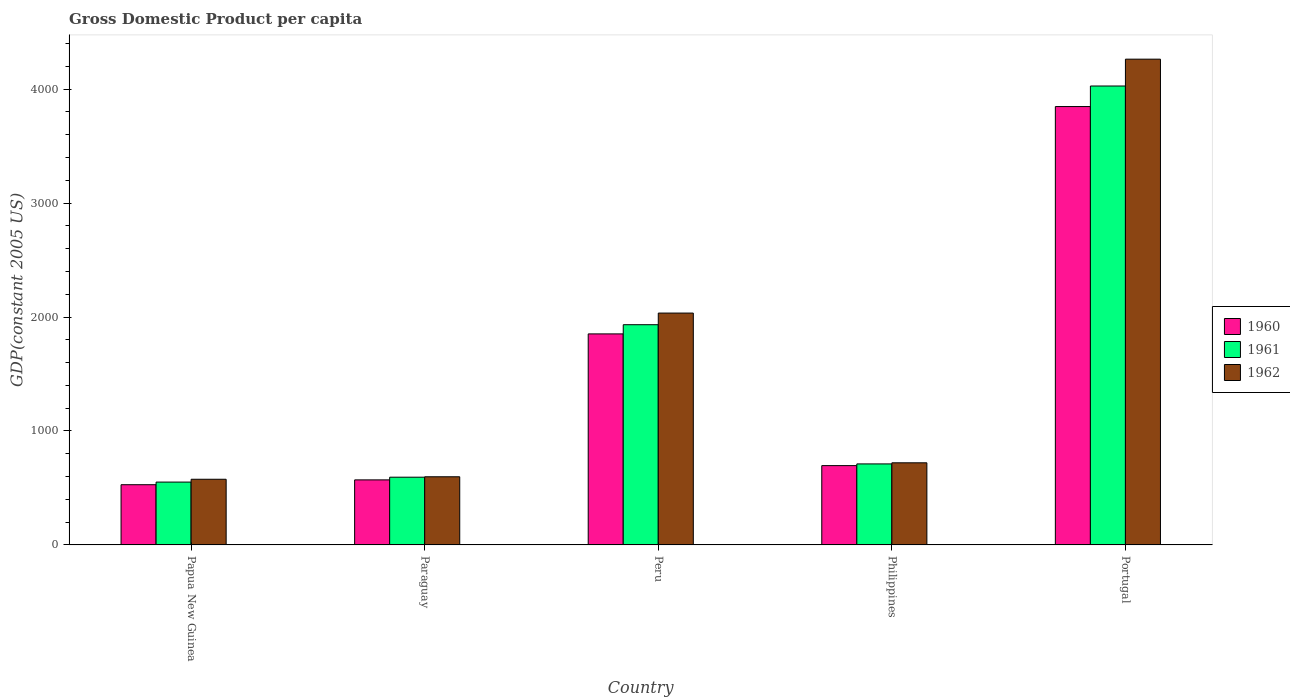How many groups of bars are there?
Provide a succinct answer. 5. Are the number of bars per tick equal to the number of legend labels?
Your answer should be very brief. Yes. Are the number of bars on each tick of the X-axis equal?
Make the answer very short. Yes. How many bars are there on the 5th tick from the right?
Your response must be concise. 3. What is the label of the 4th group of bars from the left?
Your response must be concise. Philippines. What is the GDP per capita in 1962 in Paraguay?
Make the answer very short. 598.08. Across all countries, what is the maximum GDP per capita in 1962?
Make the answer very short. 4262.56. Across all countries, what is the minimum GDP per capita in 1962?
Your answer should be compact. 576.26. In which country was the GDP per capita in 1961 maximum?
Your response must be concise. Portugal. In which country was the GDP per capita in 1962 minimum?
Ensure brevity in your answer.  Papua New Guinea. What is the total GDP per capita in 1960 in the graph?
Give a very brief answer. 7493.66. What is the difference between the GDP per capita in 1962 in Papua New Guinea and that in Peru?
Your answer should be very brief. -1458.28. What is the difference between the GDP per capita in 1961 in Paraguay and the GDP per capita in 1962 in Portugal?
Give a very brief answer. -3668.18. What is the average GDP per capita in 1960 per country?
Ensure brevity in your answer.  1498.73. What is the difference between the GDP per capita of/in 1961 and GDP per capita of/in 1962 in Peru?
Offer a very short reply. -102.11. What is the ratio of the GDP per capita in 1961 in Peru to that in Portugal?
Keep it short and to the point. 0.48. Is the GDP per capita in 1962 in Paraguay less than that in Portugal?
Your answer should be compact. Yes. What is the difference between the highest and the second highest GDP per capita in 1961?
Keep it short and to the point. 2094.64. What is the difference between the highest and the lowest GDP per capita in 1962?
Make the answer very short. 3686.3. In how many countries, is the GDP per capita in 1960 greater than the average GDP per capita in 1960 taken over all countries?
Offer a very short reply. 2. Is the sum of the GDP per capita in 1962 in Paraguay and Peru greater than the maximum GDP per capita in 1961 across all countries?
Your answer should be very brief. No. Does the graph contain any zero values?
Your answer should be very brief. No. Does the graph contain grids?
Keep it short and to the point. No. Where does the legend appear in the graph?
Offer a terse response. Center right. How many legend labels are there?
Provide a short and direct response. 3. How are the legend labels stacked?
Keep it short and to the point. Vertical. What is the title of the graph?
Your response must be concise. Gross Domestic Product per capita. Does "1963" appear as one of the legend labels in the graph?
Your answer should be very brief. No. What is the label or title of the Y-axis?
Offer a very short reply. GDP(constant 2005 US). What is the GDP(constant 2005 US) of 1960 in Papua New Guinea?
Offer a very short reply. 528.4. What is the GDP(constant 2005 US) of 1961 in Papua New Guinea?
Your answer should be very brief. 551.5. What is the GDP(constant 2005 US) in 1962 in Papua New Guinea?
Your response must be concise. 576.26. What is the GDP(constant 2005 US) of 1960 in Paraguay?
Provide a succinct answer. 570.76. What is the GDP(constant 2005 US) in 1961 in Paraguay?
Offer a terse response. 594.38. What is the GDP(constant 2005 US) in 1962 in Paraguay?
Keep it short and to the point. 598.08. What is the GDP(constant 2005 US) in 1960 in Peru?
Give a very brief answer. 1851.77. What is the GDP(constant 2005 US) in 1961 in Peru?
Provide a succinct answer. 1932.43. What is the GDP(constant 2005 US) of 1962 in Peru?
Offer a very short reply. 2034.54. What is the GDP(constant 2005 US) of 1960 in Philippines?
Provide a succinct answer. 696.02. What is the GDP(constant 2005 US) of 1961 in Philippines?
Your response must be concise. 710.98. What is the GDP(constant 2005 US) of 1962 in Philippines?
Your answer should be compact. 720.61. What is the GDP(constant 2005 US) of 1960 in Portugal?
Offer a terse response. 3846.7. What is the GDP(constant 2005 US) in 1961 in Portugal?
Your response must be concise. 4027.06. What is the GDP(constant 2005 US) of 1962 in Portugal?
Provide a short and direct response. 4262.56. Across all countries, what is the maximum GDP(constant 2005 US) in 1960?
Offer a very short reply. 3846.7. Across all countries, what is the maximum GDP(constant 2005 US) in 1961?
Ensure brevity in your answer.  4027.06. Across all countries, what is the maximum GDP(constant 2005 US) in 1962?
Offer a very short reply. 4262.56. Across all countries, what is the minimum GDP(constant 2005 US) in 1960?
Offer a very short reply. 528.4. Across all countries, what is the minimum GDP(constant 2005 US) in 1961?
Keep it short and to the point. 551.5. Across all countries, what is the minimum GDP(constant 2005 US) of 1962?
Ensure brevity in your answer.  576.26. What is the total GDP(constant 2005 US) of 1960 in the graph?
Your answer should be very brief. 7493.66. What is the total GDP(constant 2005 US) of 1961 in the graph?
Make the answer very short. 7816.36. What is the total GDP(constant 2005 US) in 1962 in the graph?
Make the answer very short. 8192.03. What is the difference between the GDP(constant 2005 US) in 1960 in Papua New Guinea and that in Paraguay?
Your answer should be very brief. -42.36. What is the difference between the GDP(constant 2005 US) in 1961 in Papua New Guinea and that in Paraguay?
Keep it short and to the point. -42.88. What is the difference between the GDP(constant 2005 US) of 1962 in Papua New Guinea and that in Paraguay?
Offer a very short reply. -21.82. What is the difference between the GDP(constant 2005 US) of 1960 in Papua New Guinea and that in Peru?
Offer a very short reply. -1323.37. What is the difference between the GDP(constant 2005 US) of 1961 in Papua New Guinea and that in Peru?
Provide a short and direct response. -1380.92. What is the difference between the GDP(constant 2005 US) of 1962 in Papua New Guinea and that in Peru?
Offer a terse response. -1458.28. What is the difference between the GDP(constant 2005 US) in 1960 in Papua New Guinea and that in Philippines?
Offer a very short reply. -167.62. What is the difference between the GDP(constant 2005 US) in 1961 in Papua New Guinea and that in Philippines?
Your answer should be very brief. -159.48. What is the difference between the GDP(constant 2005 US) in 1962 in Papua New Guinea and that in Philippines?
Give a very brief answer. -144.35. What is the difference between the GDP(constant 2005 US) of 1960 in Papua New Guinea and that in Portugal?
Give a very brief answer. -3318.3. What is the difference between the GDP(constant 2005 US) of 1961 in Papua New Guinea and that in Portugal?
Your response must be concise. -3475.56. What is the difference between the GDP(constant 2005 US) of 1962 in Papua New Guinea and that in Portugal?
Your answer should be compact. -3686.3. What is the difference between the GDP(constant 2005 US) of 1960 in Paraguay and that in Peru?
Ensure brevity in your answer.  -1281.01. What is the difference between the GDP(constant 2005 US) in 1961 in Paraguay and that in Peru?
Ensure brevity in your answer.  -1338.04. What is the difference between the GDP(constant 2005 US) of 1962 in Paraguay and that in Peru?
Provide a short and direct response. -1436.46. What is the difference between the GDP(constant 2005 US) in 1960 in Paraguay and that in Philippines?
Provide a short and direct response. -125.26. What is the difference between the GDP(constant 2005 US) of 1961 in Paraguay and that in Philippines?
Your response must be concise. -116.6. What is the difference between the GDP(constant 2005 US) of 1962 in Paraguay and that in Philippines?
Provide a succinct answer. -122.53. What is the difference between the GDP(constant 2005 US) in 1960 in Paraguay and that in Portugal?
Offer a very short reply. -3275.94. What is the difference between the GDP(constant 2005 US) in 1961 in Paraguay and that in Portugal?
Your answer should be very brief. -3432.68. What is the difference between the GDP(constant 2005 US) of 1962 in Paraguay and that in Portugal?
Make the answer very short. -3664.48. What is the difference between the GDP(constant 2005 US) in 1960 in Peru and that in Philippines?
Ensure brevity in your answer.  1155.75. What is the difference between the GDP(constant 2005 US) in 1961 in Peru and that in Philippines?
Offer a very short reply. 1221.44. What is the difference between the GDP(constant 2005 US) in 1962 in Peru and that in Philippines?
Offer a terse response. 1313.93. What is the difference between the GDP(constant 2005 US) of 1960 in Peru and that in Portugal?
Make the answer very short. -1994.93. What is the difference between the GDP(constant 2005 US) of 1961 in Peru and that in Portugal?
Your response must be concise. -2094.64. What is the difference between the GDP(constant 2005 US) in 1962 in Peru and that in Portugal?
Keep it short and to the point. -2228.02. What is the difference between the GDP(constant 2005 US) in 1960 in Philippines and that in Portugal?
Offer a very short reply. -3150.68. What is the difference between the GDP(constant 2005 US) of 1961 in Philippines and that in Portugal?
Ensure brevity in your answer.  -3316.08. What is the difference between the GDP(constant 2005 US) in 1962 in Philippines and that in Portugal?
Your response must be concise. -3541.95. What is the difference between the GDP(constant 2005 US) in 1960 in Papua New Guinea and the GDP(constant 2005 US) in 1961 in Paraguay?
Offer a terse response. -65.98. What is the difference between the GDP(constant 2005 US) in 1960 in Papua New Guinea and the GDP(constant 2005 US) in 1962 in Paraguay?
Provide a short and direct response. -69.68. What is the difference between the GDP(constant 2005 US) in 1961 in Papua New Guinea and the GDP(constant 2005 US) in 1962 in Paraguay?
Offer a very short reply. -46.57. What is the difference between the GDP(constant 2005 US) of 1960 in Papua New Guinea and the GDP(constant 2005 US) of 1961 in Peru?
Offer a terse response. -1404.03. What is the difference between the GDP(constant 2005 US) in 1960 in Papua New Guinea and the GDP(constant 2005 US) in 1962 in Peru?
Provide a succinct answer. -1506.14. What is the difference between the GDP(constant 2005 US) of 1961 in Papua New Guinea and the GDP(constant 2005 US) of 1962 in Peru?
Provide a short and direct response. -1483.04. What is the difference between the GDP(constant 2005 US) of 1960 in Papua New Guinea and the GDP(constant 2005 US) of 1961 in Philippines?
Give a very brief answer. -182.58. What is the difference between the GDP(constant 2005 US) in 1960 in Papua New Guinea and the GDP(constant 2005 US) in 1962 in Philippines?
Make the answer very short. -192.21. What is the difference between the GDP(constant 2005 US) in 1961 in Papua New Guinea and the GDP(constant 2005 US) in 1962 in Philippines?
Provide a succinct answer. -169.1. What is the difference between the GDP(constant 2005 US) of 1960 in Papua New Guinea and the GDP(constant 2005 US) of 1961 in Portugal?
Make the answer very short. -3498.66. What is the difference between the GDP(constant 2005 US) in 1960 in Papua New Guinea and the GDP(constant 2005 US) in 1962 in Portugal?
Make the answer very short. -3734.16. What is the difference between the GDP(constant 2005 US) of 1961 in Papua New Guinea and the GDP(constant 2005 US) of 1962 in Portugal?
Give a very brief answer. -3711.06. What is the difference between the GDP(constant 2005 US) of 1960 in Paraguay and the GDP(constant 2005 US) of 1961 in Peru?
Ensure brevity in your answer.  -1361.67. What is the difference between the GDP(constant 2005 US) in 1960 in Paraguay and the GDP(constant 2005 US) in 1962 in Peru?
Your answer should be compact. -1463.78. What is the difference between the GDP(constant 2005 US) of 1961 in Paraguay and the GDP(constant 2005 US) of 1962 in Peru?
Your answer should be very brief. -1440.15. What is the difference between the GDP(constant 2005 US) in 1960 in Paraguay and the GDP(constant 2005 US) in 1961 in Philippines?
Keep it short and to the point. -140.22. What is the difference between the GDP(constant 2005 US) of 1960 in Paraguay and the GDP(constant 2005 US) of 1962 in Philippines?
Your answer should be compact. -149.84. What is the difference between the GDP(constant 2005 US) of 1961 in Paraguay and the GDP(constant 2005 US) of 1962 in Philippines?
Make the answer very short. -126.22. What is the difference between the GDP(constant 2005 US) of 1960 in Paraguay and the GDP(constant 2005 US) of 1961 in Portugal?
Offer a very short reply. -3456.3. What is the difference between the GDP(constant 2005 US) of 1960 in Paraguay and the GDP(constant 2005 US) of 1962 in Portugal?
Offer a terse response. -3691.8. What is the difference between the GDP(constant 2005 US) in 1961 in Paraguay and the GDP(constant 2005 US) in 1962 in Portugal?
Provide a short and direct response. -3668.18. What is the difference between the GDP(constant 2005 US) of 1960 in Peru and the GDP(constant 2005 US) of 1961 in Philippines?
Keep it short and to the point. 1140.79. What is the difference between the GDP(constant 2005 US) in 1960 in Peru and the GDP(constant 2005 US) in 1962 in Philippines?
Give a very brief answer. 1131.17. What is the difference between the GDP(constant 2005 US) in 1961 in Peru and the GDP(constant 2005 US) in 1962 in Philippines?
Provide a short and direct response. 1211.82. What is the difference between the GDP(constant 2005 US) in 1960 in Peru and the GDP(constant 2005 US) in 1961 in Portugal?
Your answer should be compact. -2175.29. What is the difference between the GDP(constant 2005 US) in 1960 in Peru and the GDP(constant 2005 US) in 1962 in Portugal?
Your response must be concise. -2410.79. What is the difference between the GDP(constant 2005 US) of 1961 in Peru and the GDP(constant 2005 US) of 1962 in Portugal?
Keep it short and to the point. -2330.13. What is the difference between the GDP(constant 2005 US) of 1960 in Philippines and the GDP(constant 2005 US) of 1961 in Portugal?
Provide a succinct answer. -3331.04. What is the difference between the GDP(constant 2005 US) in 1960 in Philippines and the GDP(constant 2005 US) in 1962 in Portugal?
Offer a terse response. -3566.54. What is the difference between the GDP(constant 2005 US) in 1961 in Philippines and the GDP(constant 2005 US) in 1962 in Portugal?
Offer a very short reply. -3551.57. What is the average GDP(constant 2005 US) of 1960 per country?
Offer a terse response. 1498.73. What is the average GDP(constant 2005 US) in 1961 per country?
Your answer should be compact. 1563.27. What is the average GDP(constant 2005 US) of 1962 per country?
Keep it short and to the point. 1638.41. What is the difference between the GDP(constant 2005 US) of 1960 and GDP(constant 2005 US) of 1961 in Papua New Guinea?
Offer a terse response. -23.1. What is the difference between the GDP(constant 2005 US) in 1960 and GDP(constant 2005 US) in 1962 in Papua New Guinea?
Offer a very short reply. -47.85. What is the difference between the GDP(constant 2005 US) of 1961 and GDP(constant 2005 US) of 1962 in Papua New Guinea?
Offer a terse response. -24.75. What is the difference between the GDP(constant 2005 US) in 1960 and GDP(constant 2005 US) in 1961 in Paraguay?
Ensure brevity in your answer.  -23.62. What is the difference between the GDP(constant 2005 US) of 1960 and GDP(constant 2005 US) of 1962 in Paraguay?
Provide a short and direct response. -27.32. What is the difference between the GDP(constant 2005 US) of 1961 and GDP(constant 2005 US) of 1962 in Paraguay?
Ensure brevity in your answer.  -3.69. What is the difference between the GDP(constant 2005 US) in 1960 and GDP(constant 2005 US) in 1961 in Peru?
Your answer should be compact. -80.65. What is the difference between the GDP(constant 2005 US) in 1960 and GDP(constant 2005 US) in 1962 in Peru?
Ensure brevity in your answer.  -182.77. What is the difference between the GDP(constant 2005 US) in 1961 and GDP(constant 2005 US) in 1962 in Peru?
Your response must be concise. -102.11. What is the difference between the GDP(constant 2005 US) of 1960 and GDP(constant 2005 US) of 1961 in Philippines?
Provide a short and direct response. -14.96. What is the difference between the GDP(constant 2005 US) of 1960 and GDP(constant 2005 US) of 1962 in Philippines?
Offer a terse response. -24.59. What is the difference between the GDP(constant 2005 US) in 1961 and GDP(constant 2005 US) in 1962 in Philippines?
Provide a short and direct response. -9.62. What is the difference between the GDP(constant 2005 US) of 1960 and GDP(constant 2005 US) of 1961 in Portugal?
Offer a terse response. -180.36. What is the difference between the GDP(constant 2005 US) of 1960 and GDP(constant 2005 US) of 1962 in Portugal?
Provide a succinct answer. -415.86. What is the difference between the GDP(constant 2005 US) in 1961 and GDP(constant 2005 US) in 1962 in Portugal?
Provide a succinct answer. -235.5. What is the ratio of the GDP(constant 2005 US) of 1960 in Papua New Guinea to that in Paraguay?
Offer a terse response. 0.93. What is the ratio of the GDP(constant 2005 US) of 1961 in Papua New Guinea to that in Paraguay?
Your response must be concise. 0.93. What is the ratio of the GDP(constant 2005 US) in 1962 in Papua New Guinea to that in Paraguay?
Your answer should be very brief. 0.96. What is the ratio of the GDP(constant 2005 US) of 1960 in Papua New Guinea to that in Peru?
Your response must be concise. 0.29. What is the ratio of the GDP(constant 2005 US) in 1961 in Papua New Guinea to that in Peru?
Keep it short and to the point. 0.29. What is the ratio of the GDP(constant 2005 US) of 1962 in Papua New Guinea to that in Peru?
Your response must be concise. 0.28. What is the ratio of the GDP(constant 2005 US) in 1960 in Papua New Guinea to that in Philippines?
Offer a very short reply. 0.76. What is the ratio of the GDP(constant 2005 US) in 1961 in Papua New Guinea to that in Philippines?
Provide a short and direct response. 0.78. What is the ratio of the GDP(constant 2005 US) in 1962 in Papua New Guinea to that in Philippines?
Offer a very short reply. 0.8. What is the ratio of the GDP(constant 2005 US) in 1960 in Papua New Guinea to that in Portugal?
Your answer should be very brief. 0.14. What is the ratio of the GDP(constant 2005 US) of 1961 in Papua New Guinea to that in Portugal?
Ensure brevity in your answer.  0.14. What is the ratio of the GDP(constant 2005 US) in 1962 in Papua New Guinea to that in Portugal?
Keep it short and to the point. 0.14. What is the ratio of the GDP(constant 2005 US) in 1960 in Paraguay to that in Peru?
Give a very brief answer. 0.31. What is the ratio of the GDP(constant 2005 US) in 1961 in Paraguay to that in Peru?
Your answer should be compact. 0.31. What is the ratio of the GDP(constant 2005 US) in 1962 in Paraguay to that in Peru?
Your answer should be very brief. 0.29. What is the ratio of the GDP(constant 2005 US) of 1960 in Paraguay to that in Philippines?
Make the answer very short. 0.82. What is the ratio of the GDP(constant 2005 US) in 1961 in Paraguay to that in Philippines?
Keep it short and to the point. 0.84. What is the ratio of the GDP(constant 2005 US) of 1962 in Paraguay to that in Philippines?
Your response must be concise. 0.83. What is the ratio of the GDP(constant 2005 US) in 1960 in Paraguay to that in Portugal?
Ensure brevity in your answer.  0.15. What is the ratio of the GDP(constant 2005 US) in 1961 in Paraguay to that in Portugal?
Offer a very short reply. 0.15. What is the ratio of the GDP(constant 2005 US) in 1962 in Paraguay to that in Portugal?
Offer a terse response. 0.14. What is the ratio of the GDP(constant 2005 US) of 1960 in Peru to that in Philippines?
Your response must be concise. 2.66. What is the ratio of the GDP(constant 2005 US) of 1961 in Peru to that in Philippines?
Offer a very short reply. 2.72. What is the ratio of the GDP(constant 2005 US) in 1962 in Peru to that in Philippines?
Ensure brevity in your answer.  2.82. What is the ratio of the GDP(constant 2005 US) in 1960 in Peru to that in Portugal?
Provide a succinct answer. 0.48. What is the ratio of the GDP(constant 2005 US) of 1961 in Peru to that in Portugal?
Offer a terse response. 0.48. What is the ratio of the GDP(constant 2005 US) of 1962 in Peru to that in Portugal?
Provide a short and direct response. 0.48. What is the ratio of the GDP(constant 2005 US) of 1960 in Philippines to that in Portugal?
Your answer should be compact. 0.18. What is the ratio of the GDP(constant 2005 US) in 1961 in Philippines to that in Portugal?
Offer a terse response. 0.18. What is the ratio of the GDP(constant 2005 US) of 1962 in Philippines to that in Portugal?
Keep it short and to the point. 0.17. What is the difference between the highest and the second highest GDP(constant 2005 US) of 1960?
Your answer should be very brief. 1994.93. What is the difference between the highest and the second highest GDP(constant 2005 US) of 1961?
Your answer should be compact. 2094.64. What is the difference between the highest and the second highest GDP(constant 2005 US) of 1962?
Your response must be concise. 2228.02. What is the difference between the highest and the lowest GDP(constant 2005 US) in 1960?
Offer a very short reply. 3318.3. What is the difference between the highest and the lowest GDP(constant 2005 US) in 1961?
Make the answer very short. 3475.56. What is the difference between the highest and the lowest GDP(constant 2005 US) of 1962?
Give a very brief answer. 3686.3. 